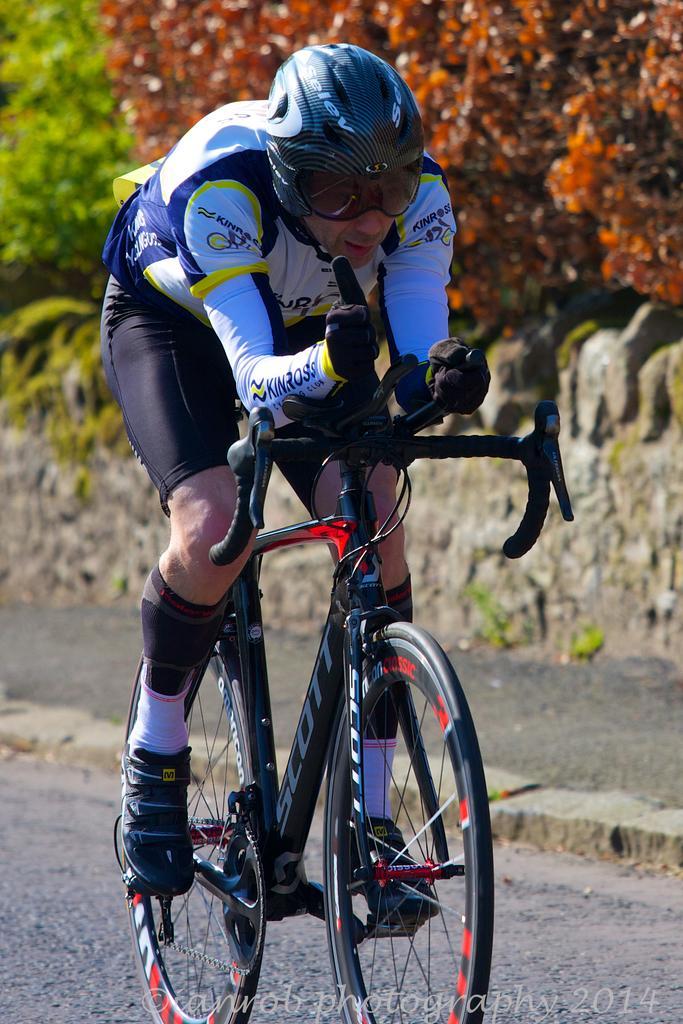Describe this image in one or two sentences. In this image there is a person cycling on the road. Behind him there is a wall. There are trees. There is some text at the bottom of the image. 